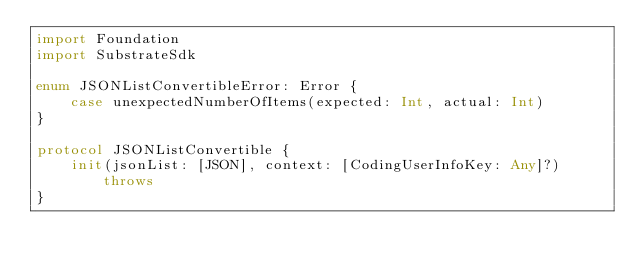<code> <loc_0><loc_0><loc_500><loc_500><_Swift_>import Foundation
import SubstrateSdk

enum JSONListConvertibleError: Error {
    case unexpectedNumberOfItems(expected: Int, actual: Int)
}

protocol JSONListConvertible {
    init(jsonList: [JSON], context: [CodingUserInfoKey: Any]?) throws
}
</code> 